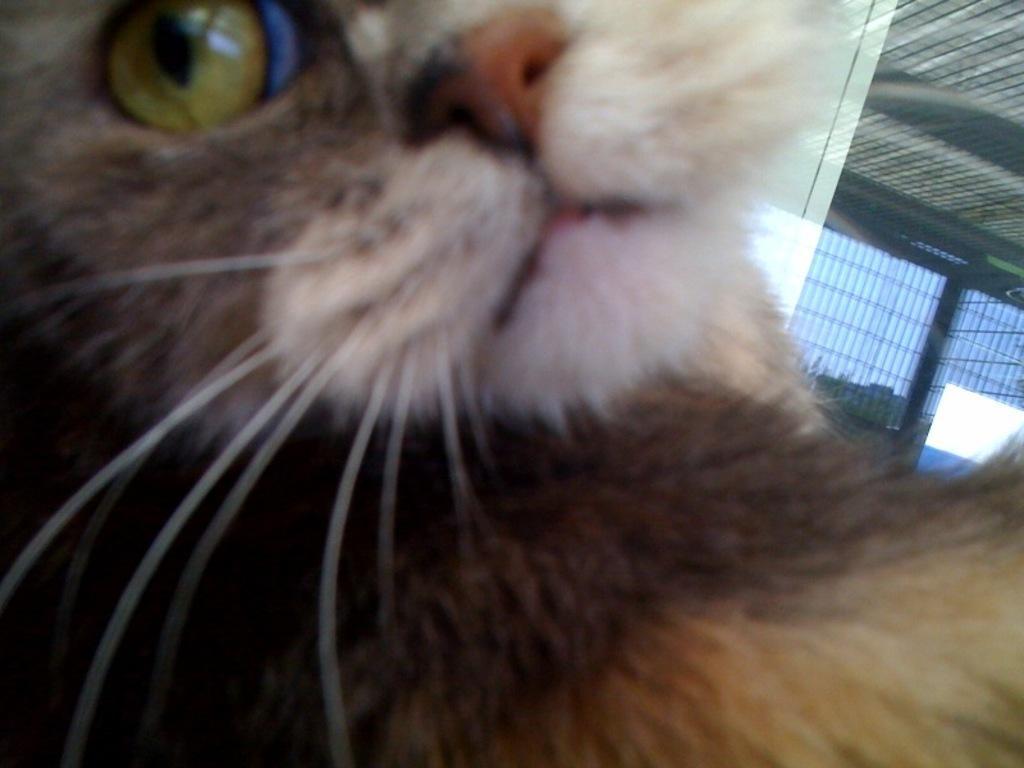Please provide a concise description of this image. In the center of the image a cat is present. On the right side of the image we can see window, roof and sky are present. 